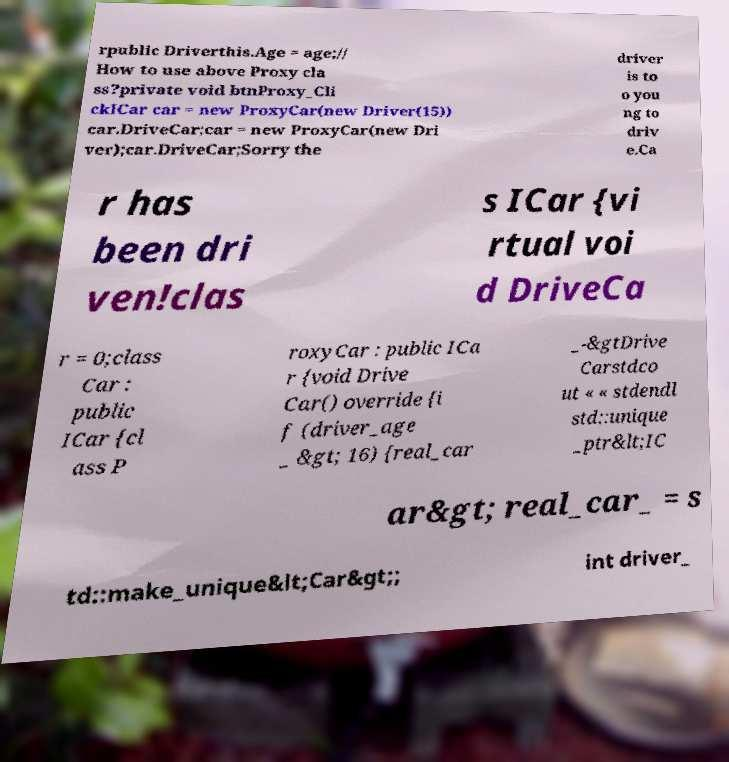Please identify and transcribe the text found in this image. rpublic Driverthis.Age = age;// How to use above Proxy cla ss?private void btnProxy_Cli ckICar car = new ProxyCar(new Driver(15)) car.DriveCar;car = new ProxyCar(new Dri ver);car.DriveCar;Sorry the driver is to o you ng to driv e.Ca r has been dri ven!clas s ICar {vi rtual voi d DriveCa r = 0;class Car : public ICar {cl ass P roxyCar : public ICa r {void Drive Car() override {i f (driver_age _ &gt; 16) {real_car _-&gtDrive Carstdco ut « « stdendl std::unique _ptr&lt;IC ar&gt; real_car_ = s td::make_unique&lt;Car&gt;; int driver_ 